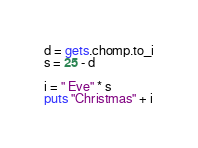Convert code to text. <code><loc_0><loc_0><loc_500><loc_500><_Ruby_>d = gets.chomp.to_i
s = 25 - d

i = " Eve" * s
puts "Christmas" + i</code> 